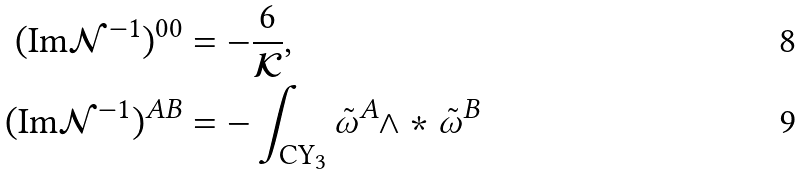<formula> <loc_0><loc_0><loc_500><loc_500>( \text {Im} \mathcal { N } ^ { - 1 } ) ^ { 0 0 } & = - \frac { 6 } { \mathcal { K } } , \\ ( \text {Im} \mathcal { N } ^ { - 1 } ) ^ { A B } & = - \int _ { \text {CY} _ { 3 } } \tilde { \omega } ^ { A } \wedge * \tilde { \omega } ^ { B }</formula> 